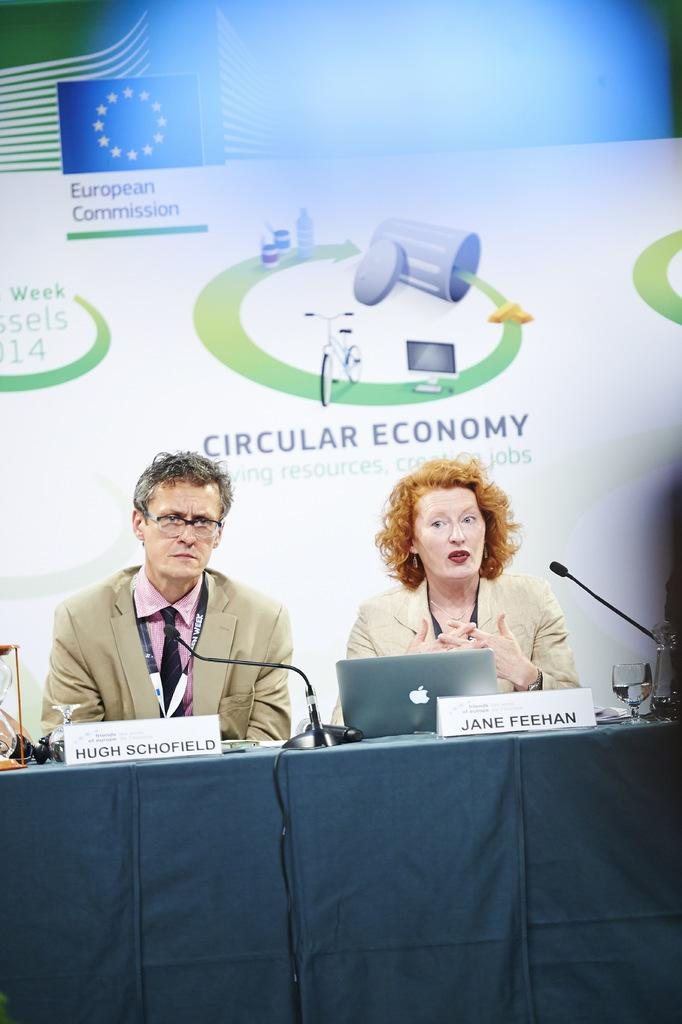What are the two people in the image doing? There is a man and a woman sitting in the image. What objects are in front of them? There are microphones and a system in front of them. How can we identify the individuals in the image? There are name plates in the image. What can be seen in the background? There is a poster visible in the background. How many thumbs can be seen on the man's hand in the image? There is no visible thumb on the man's hand in the image. What type of plants are growing on the woman's head in the image? There are no plants growing on the woman's head in the image. 